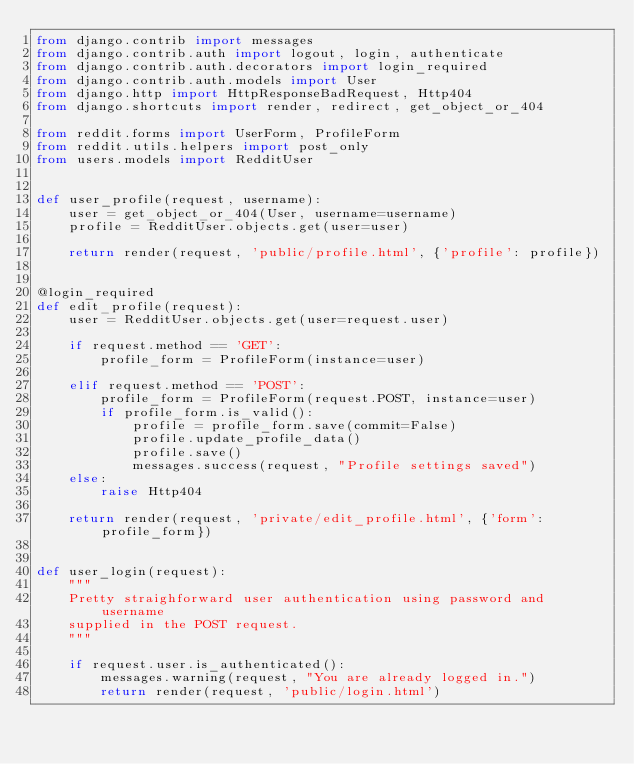<code> <loc_0><loc_0><loc_500><loc_500><_Python_>from django.contrib import messages
from django.contrib.auth import logout, login, authenticate
from django.contrib.auth.decorators import login_required
from django.contrib.auth.models import User
from django.http import HttpResponseBadRequest, Http404
from django.shortcuts import render, redirect, get_object_or_404

from reddit.forms import UserForm, ProfileForm
from reddit.utils.helpers import post_only
from users.models import RedditUser


def user_profile(request, username):
    user = get_object_or_404(User, username=username)
    profile = RedditUser.objects.get(user=user)

    return render(request, 'public/profile.html', {'profile': profile})


@login_required
def edit_profile(request):
    user = RedditUser.objects.get(user=request.user)

    if request.method == 'GET':
        profile_form = ProfileForm(instance=user)

    elif request.method == 'POST':
        profile_form = ProfileForm(request.POST, instance=user)
        if profile_form.is_valid():
            profile = profile_form.save(commit=False)
            profile.update_profile_data()
            profile.save()
            messages.success(request, "Profile settings saved")
    else:
        raise Http404

    return render(request, 'private/edit_profile.html', {'form': profile_form})


def user_login(request):
    """
    Pretty straighforward user authentication using password and username
    supplied in the POST request.
    """

    if request.user.is_authenticated():
        messages.warning(request, "You are already logged in.")
        return render(request, 'public/login.html')
</code> 